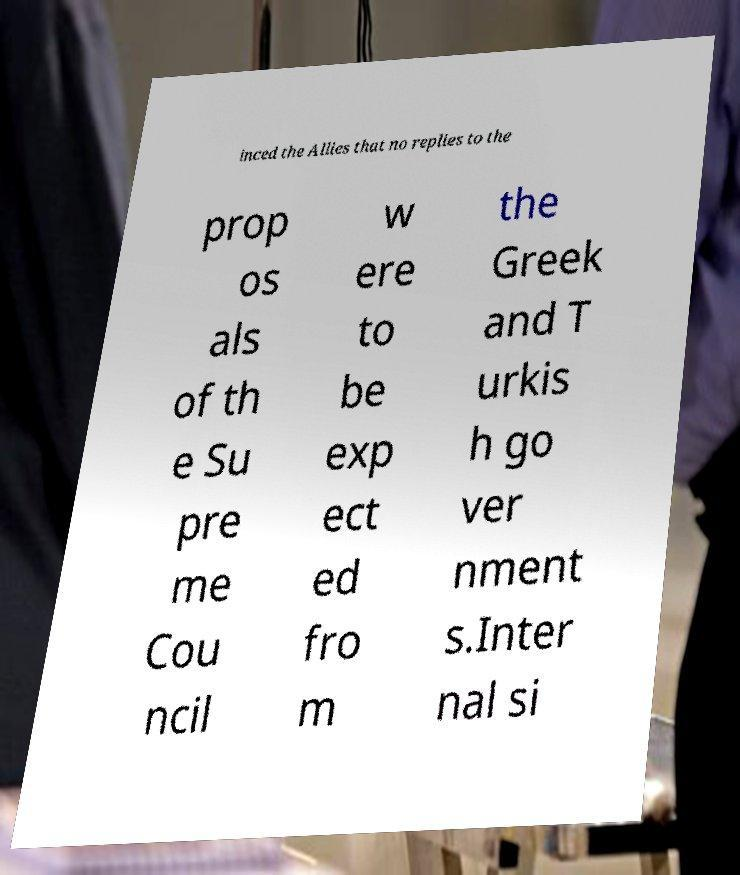There's text embedded in this image that I need extracted. Can you transcribe it verbatim? inced the Allies that no replies to the prop os als of th e Su pre me Cou ncil w ere to be exp ect ed fro m the Greek and T urkis h go ver nment s.Inter nal si 